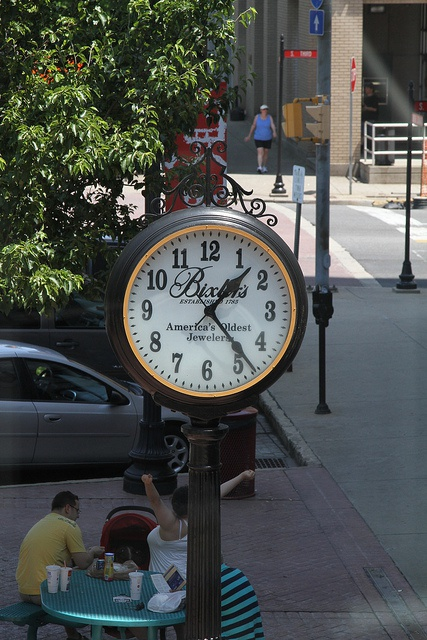Describe the objects in this image and their specific colors. I can see clock in gray, darkgray, black, and lightgray tones, car in gray, black, and darkblue tones, dining table in gray, blue, black, and darkblue tones, people in gray, olive, and black tones, and people in gray and black tones in this image. 